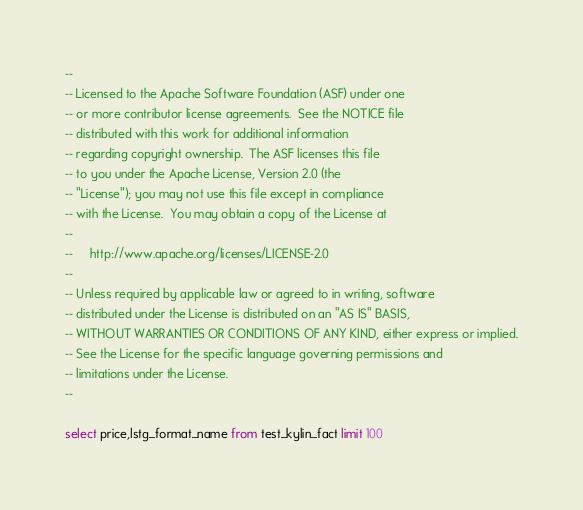<code> <loc_0><loc_0><loc_500><loc_500><_SQL_>--
-- Licensed to the Apache Software Foundation (ASF) under one
-- or more contributor license agreements.  See the NOTICE file
-- distributed with this work for additional information
-- regarding copyright ownership.  The ASF licenses this file
-- to you under the Apache License, Version 2.0 (the
-- "License"); you may not use this file except in compliance
-- with the License.  You may obtain a copy of the License at
--
--     http://www.apache.org/licenses/LICENSE-2.0
--
-- Unless required by applicable law or agreed to in writing, software
-- distributed under the License is distributed on an "AS IS" BASIS,
-- WITHOUT WARRANTIES OR CONDITIONS OF ANY KIND, either express or implied.
-- See the License for the specific language governing permissions and
-- limitations under the License.
--

select price,lstg_format_name from test_kylin_fact limit 100
</code> 